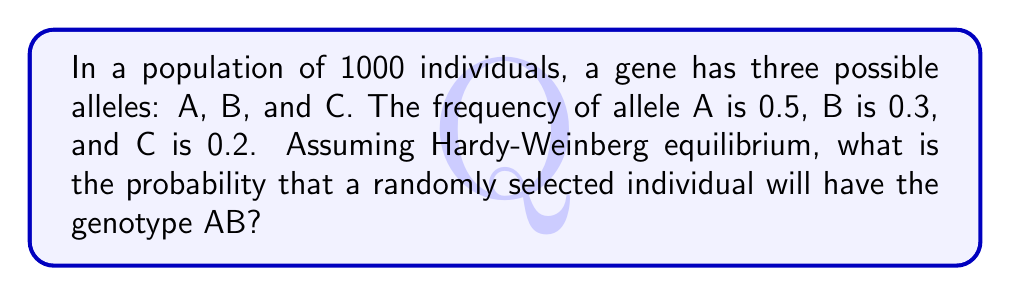Can you solve this math problem? To solve this problem, we'll follow these steps:

1. Recall the Hardy-Weinberg principle:
   For a gene with two alleles, p and q, where p + q = 1:
   $$p^2 + 2pq + q^2 = 1$$

2. In our case, we have three alleles, so we'll use an extension of this principle:
   $$p^2 + q^2 + r^2 + 2pq + 2pr + 2qr = 1$$
   where p, q, and r are the frequencies of alleles A, B, and C respectively.

3. We're given:
   p (frequency of A) = 0.5
   q (frequency of B) = 0.3
   r (frequency of C) = 0.2

4. The probability of the AB genotype is represented by the term 2pq in the equation.

5. Calculate 2pq:
   $$2pq = 2 * 0.5 * 0.3 = 0.3$$

6. Therefore, the probability of randomly selecting an individual with genotype AB is 0.3 or 30%.
Answer: 0.3 